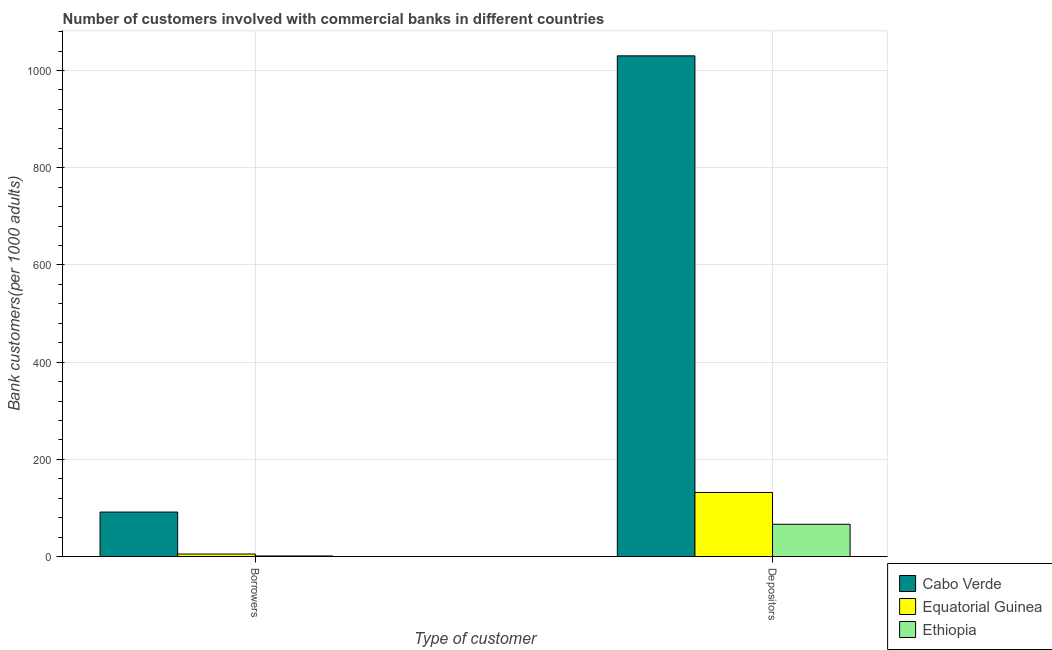How many different coloured bars are there?
Provide a short and direct response. 3. Are the number of bars on each tick of the X-axis equal?
Make the answer very short. Yes. What is the label of the 1st group of bars from the left?
Ensure brevity in your answer.  Borrowers. What is the number of borrowers in Cabo Verde?
Make the answer very short. 91.53. Across all countries, what is the maximum number of borrowers?
Your answer should be very brief. 91.53. Across all countries, what is the minimum number of depositors?
Keep it short and to the point. 66.42. In which country was the number of borrowers maximum?
Provide a succinct answer. Cabo Verde. In which country was the number of depositors minimum?
Give a very brief answer. Ethiopia. What is the total number of borrowers in the graph?
Your answer should be compact. 97.92. What is the difference between the number of depositors in Equatorial Guinea and that in Ethiopia?
Your answer should be very brief. 65.43. What is the difference between the number of depositors in Cabo Verde and the number of borrowers in Equatorial Guinea?
Provide a succinct answer. 1025.03. What is the average number of depositors per country?
Ensure brevity in your answer.  409.49. What is the difference between the number of borrowers and number of depositors in Ethiopia?
Make the answer very short. -65.21. What is the ratio of the number of borrowers in Ethiopia to that in Equatorial Guinea?
Offer a terse response. 0.23. Is the number of borrowers in Ethiopia less than that in Cabo Verde?
Keep it short and to the point. Yes. In how many countries, is the number of depositors greater than the average number of depositors taken over all countries?
Offer a terse response. 1. What does the 2nd bar from the left in Depositors represents?
Provide a short and direct response. Equatorial Guinea. What does the 3rd bar from the right in Borrowers represents?
Keep it short and to the point. Cabo Verde. How many bars are there?
Make the answer very short. 6. How many countries are there in the graph?
Keep it short and to the point. 3. What is the difference between two consecutive major ticks on the Y-axis?
Give a very brief answer. 200. Where does the legend appear in the graph?
Provide a succinct answer. Bottom right. What is the title of the graph?
Ensure brevity in your answer.  Number of customers involved with commercial banks in different countries. Does "Sint Maarten (Dutch part)" appear as one of the legend labels in the graph?
Keep it short and to the point. No. What is the label or title of the X-axis?
Your response must be concise. Type of customer. What is the label or title of the Y-axis?
Provide a short and direct response. Bank customers(per 1000 adults). What is the Bank customers(per 1000 adults) in Cabo Verde in Borrowers?
Give a very brief answer. 91.53. What is the Bank customers(per 1000 adults) of Equatorial Guinea in Borrowers?
Provide a short and direct response. 5.18. What is the Bank customers(per 1000 adults) in Ethiopia in Borrowers?
Your answer should be very brief. 1.21. What is the Bank customers(per 1000 adults) of Cabo Verde in Depositors?
Make the answer very short. 1030.2. What is the Bank customers(per 1000 adults) of Equatorial Guinea in Depositors?
Make the answer very short. 131.85. What is the Bank customers(per 1000 adults) in Ethiopia in Depositors?
Provide a short and direct response. 66.42. Across all Type of customer, what is the maximum Bank customers(per 1000 adults) in Cabo Verde?
Your answer should be compact. 1030.2. Across all Type of customer, what is the maximum Bank customers(per 1000 adults) of Equatorial Guinea?
Your response must be concise. 131.85. Across all Type of customer, what is the maximum Bank customers(per 1000 adults) of Ethiopia?
Make the answer very short. 66.42. Across all Type of customer, what is the minimum Bank customers(per 1000 adults) in Cabo Verde?
Provide a succinct answer. 91.53. Across all Type of customer, what is the minimum Bank customers(per 1000 adults) of Equatorial Guinea?
Your answer should be very brief. 5.18. Across all Type of customer, what is the minimum Bank customers(per 1000 adults) in Ethiopia?
Your answer should be compact. 1.21. What is the total Bank customers(per 1000 adults) in Cabo Verde in the graph?
Your answer should be very brief. 1121.74. What is the total Bank customers(per 1000 adults) in Equatorial Guinea in the graph?
Your response must be concise. 137.02. What is the total Bank customers(per 1000 adults) in Ethiopia in the graph?
Offer a very short reply. 67.62. What is the difference between the Bank customers(per 1000 adults) of Cabo Verde in Borrowers and that in Depositors?
Make the answer very short. -938.67. What is the difference between the Bank customers(per 1000 adults) in Equatorial Guinea in Borrowers and that in Depositors?
Provide a short and direct response. -126.67. What is the difference between the Bank customers(per 1000 adults) of Ethiopia in Borrowers and that in Depositors?
Your answer should be compact. -65.21. What is the difference between the Bank customers(per 1000 adults) in Cabo Verde in Borrowers and the Bank customers(per 1000 adults) in Equatorial Guinea in Depositors?
Ensure brevity in your answer.  -40.31. What is the difference between the Bank customers(per 1000 adults) in Cabo Verde in Borrowers and the Bank customers(per 1000 adults) in Ethiopia in Depositors?
Provide a short and direct response. 25.12. What is the difference between the Bank customers(per 1000 adults) in Equatorial Guinea in Borrowers and the Bank customers(per 1000 adults) in Ethiopia in Depositors?
Your response must be concise. -61.24. What is the average Bank customers(per 1000 adults) of Cabo Verde per Type of customer?
Keep it short and to the point. 560.87. What is the average Bank customers(per 1000 adults) in Equatorial Guinea per Type of customer?
Offer a very short reply. 68.51. What is the average Bank customers(per 1000 adults) in Ethiopia per Type of customer?
Provide a short and direct response. 33.81. What is the difference between the Bank customers(per 1000 adults) of Cabo Verde and Bank customers(per 1000 adults) of Equatorial Guinea in Borrowers?
Your answer should be compact. 86.36. What is the difference between the Bank customers(per 1000 adults) of Cabo Verde and Bank customers(per 1000 adults) of Ethiopia in Borrowers?
Provide a succinct answer. 90.33. What is the difference between the Bank customers(per 1000 adults) in Equatorial Guinea and Bank customers(per 1000 adults) in Ethiopia in Borrowers?
Offer a terse response. 3.97. What is the difference between the Bank customers(per 1000 adults) in Cabo Verde and Bank customers(per 1000 adults) in Equatorial Guinea in Depositors?
Offer a terse response. 898.36. What is the difference between the Bank customers(per 1000 adults) of Cabo Verde and Bank customers(per 1000 adults) of Ethiopia in Depositors?
Ensure brevity in your answer.  963.79. What is the difference between the Bank customers(per 1000 adults) in Equatorial Guinea and Bank customers(per 1000 adults) in Ethiopia in Depositors?
Your response must be concise. 65.43. What is the ratio of the Bank customers(per 1000 adults) in Cabo Verde in Borrowers to that in Depositors?
Offer a terse response. 0.09. What is the ratio of the Bank customers(per 1000 adults) of Equatorial Guinea in Borrowers to that in Depositors?
Make the answer very short. 0.04. What is the ratio of the Bank customers(per 1000 adults) of Ethiopia in Borrowers to that in Depositors?
Your answer should be very brief. 0.02. What is the difference between the highest and the second highest Bank customers(per 1000 adults) in Cabo Verde?
Offer a terse response. 938.67. What is the difference between the highest and the second highest Bank customers(per 1000 adults) of Equatorial Guinea?
Your response must be concise. 126.67. What is the difference between the highest and the second highest Bank customers(per 1000 adults) of Ethiopia?
Your answer should be very brief. 65.21. What is the difference between the highest and the lowest Bank customers(per 1000 adults) of Cabo Verde?
Give a very brief answer. 938.67. What is the difference between the highest and the lowest Bank customers(per 1000 adults) in Equatorial Guinea?
Ensure brevity in your answer.  126.67. What is the difference between the highest and the lowest Bank customers(per 1000 adults) of Ethiopia?
Your answer should be compact. 65.21. 